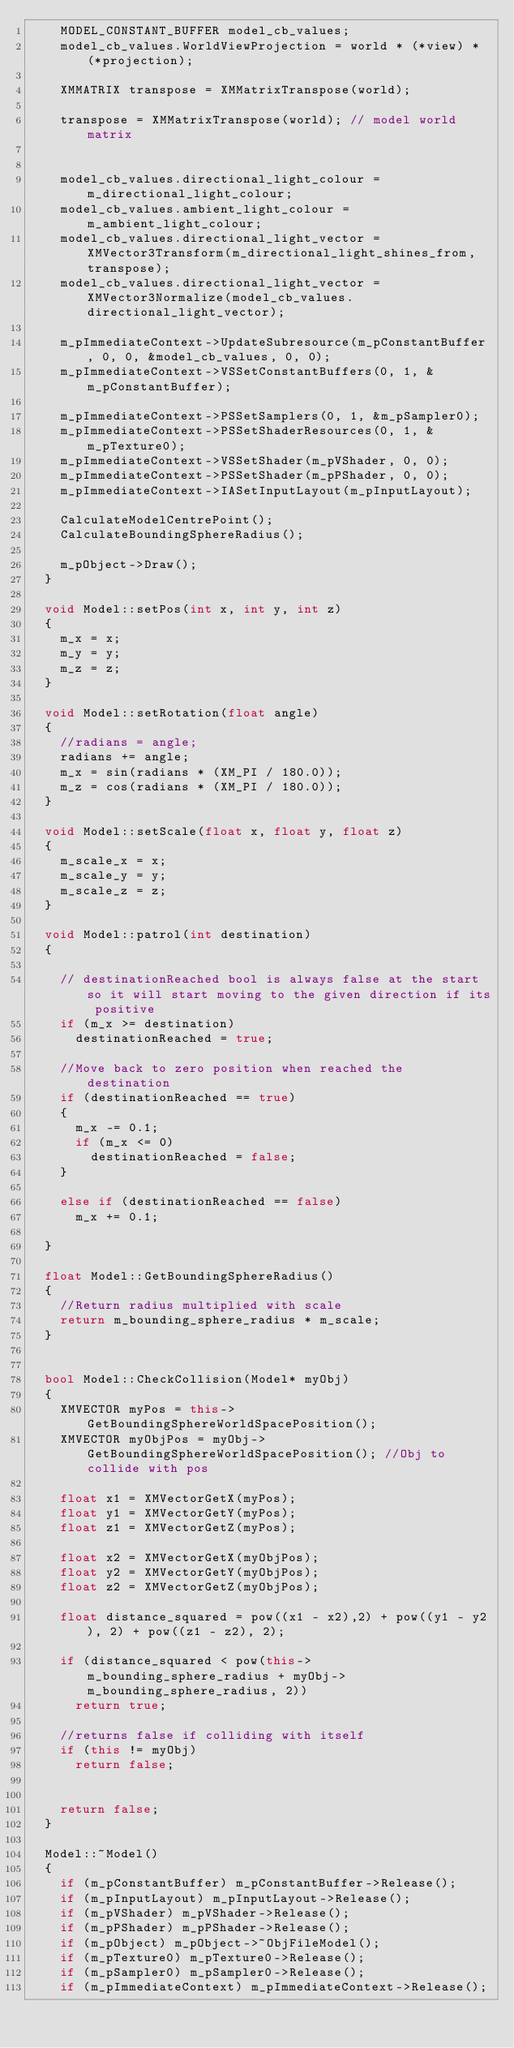Convert code to text. <code><loc_0><loc_0><loc_500><loc_500><_C++_>		MODEL_CONSTANT_BUFFER model_cb_values;
		model_cb_values.WorldViewProjection = world * (*view) * (*projection);

		XMMATRIX transpose = XMMatrixTranspose(world);

		transpose = XMMatrixTranspose(world); // model world matrix


		model_cb_values.directional_light_colour = m_directional_light_colour;
		model_cb_values.ambient_light_colour = m_ambient_light_colour;
		model_cb_values.directional_light_vector = XMVector3Transform(m_directional_light_shines_from, transpose);
		model_cb_values.directional_light_vector = XMVector3Normalize(model_cb_values.directional_light_vector);

		m_pImmediateContext->UpdateSubresource(m_pConstantBuffer, 0, 0, &model_cb_values, 0, 0);
		m_pImmediateContext->VSSetConstantBuffers(0, 1, &m_pConstantBuffer);

		m_pImmediateContext->PSSetSamplers(0, 1, &m_pSampler0);
		m_pImmediateContext->PSSetShaderResources(0, 1, &m_pTexture0);
		m_pImmediateContext->VSSetShader(m_pVShader, 0, 0);
		m_pImmediateContext->PSSetShader(m_pPShader, 0, 0);
		m_pImmediateContext->IASetInputLayout(m_pInputLayout);

		CalculateModelCentrePoint();
		CalculateBoundingSphereRadius();

		m_pObject->Draw();
	}

	void Model::setPos(int x, int y, int z)
	{
		m_x = x;
		m_y = y;
		m_z = z;
	}

	void Model::setRotation(float angle)
	{
		//radians = angle;
		radians += angle;
		m_x = sin(radians * (XM_PI / 180.0));
		m_z = cos(radians * (XM_PI / 180.0));
	}

	void Model::setScale(float x, float y, float z)
	{
		m_scale_x = x;
		m_scale_y = y;
		m_scale_z = z;
	}

	void Model::patrol(int destination)
	{

		// destinationReached bool is always false at the start so it will start moving to the given direction if its positive
		if (m_x >= destination)
			destinationReached = true;

		//Move back to zero position when reached the destination
		if (destinationReached == true)
		{
			m_x -= 0.1;
			if (m_x <= 0)
				destinationReached = false;
		}

		else if (destinationReached == false)
			m_x += 0.1;

	}

	float Model::GetBoundingSphereRadius()
	{
		//Return radius multiplied with scale
		return m_bounding_sphere_radius * m_scale;
	}


	bool Model::CheckCollision(Model* myObj)
	{
		XMVECTOR myPos = this->GetBoundingSphereWorldSpacePosition();
		XMVECTOR myObjPos = myObj->GetBoundingSphereWorldSpacePosition(); //Obj to collide with pos

		float x1 = XMVectorGetX(myPos);
		float y1 = XMVectorGetY(myPos);
		float z1 = XMVectorGetZ(myPos);

		float x2 = XMVectorGetX(myObjPos);
		float y2 = XMVectorGetY(myObjPos);
		float z2 = XMVectorGetZ(myObjPos);

		float distance_squared = pow((x1 - x2),2) + pow((y1 - y2), 2) + pow((z1 - z2), 2);

		if (distance_squared < pow(this->m_bounding_sphere_radius + myObj->m_bounding_sphere_radius, 2))
			return true;

		//returns false if colliding with itself
		if (this != myObj)
			return false;


		return false;
	}

	Model::~Model()
	{
		if (m_pConstantBuffer) m_pConstantBuffer->Release();
		if (m_pInputLayout) m_pInputLayout->Release();
		if (m_pVShader) m_pVShader->Release();
		if (m_pPShader) m_pPShader->Release();
		if (m_pObject) m_pObject->~ObjFileModel();
		if (m_pTexture0) m_pTexture0->Release();
		if (m_pSampler0) m_pSampler0->Release();
		if (m_pImmediateContext) m_pImmediateContext->Release();</code> 